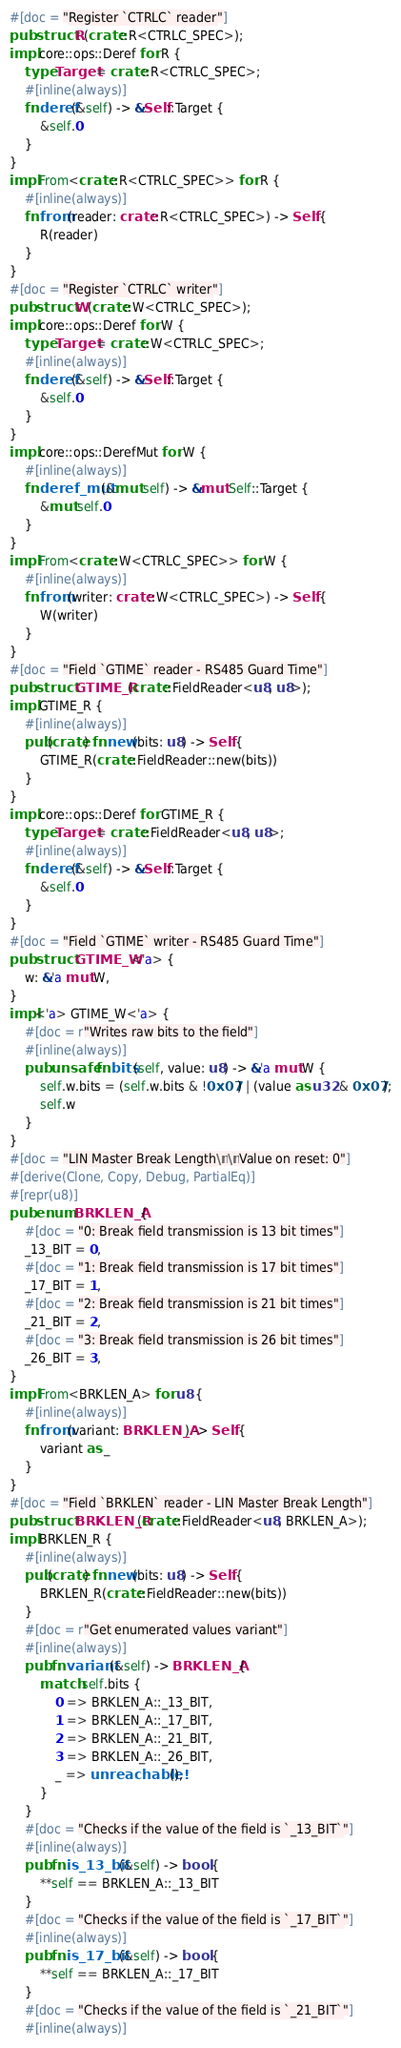<code> <loc_0><loc_0><loc_500><loc_500><_Rust_>#[doc = "Register `CTRLC` reader"]
pub struct R(crate::R<CTRLC_SPEC>);
impl core::ops::Deref for R {
    type Target = crate::R<CTRLC_SPEC>;
    #[inline(always)]
    fn deref(&self) -> &Self::Target {
        &self.0
    }
}
impl From<crate::R<CTRLC_SPEC>> for R {
    #[inline(always)]
    fn from(reader: crate::R<CTRLC_SPEC>) -> Self {
        R(reader)
    }
}
#[doc = "Register `CTRLC` writer"]
pub struct W(crate::W<CTRLC_SPEC>);
impl core::ops::Deref for W {
    type Target = crate::W<CTRLC_SPEC>;
    #[inline(always)]
    fn deref(&self) -> &Self::Target {
        &self.0
    }
}
impl core::ops::DerefMut for W {
    #[inline(always)]
    fn deref_mut(&mut self) -> &mut Self::Target {
        &mut self.0
    }
}
impl From<crate::W<CTRLC_SPEC>> for W {
    #[inline(always)]
    fn from(writer: crate::W<CTRLC_SPEC>) -> Self {
        W(writer)
    }
}
#[doc = "Field `GTIME` reader - RS485 Guard Time"]
pub struct GTIME_R(crate::FieldReader<u8, u8>);
impl GTIME_R {
    #[inline(always)]
    pub(crate) fn new(bits: u8) -> Self {
        GTIME_R(crate::FieldReader::new(bits))
    }
}
impl core::ops::Deref for GTIME_R {
    type Target = crate::FieldReader<u8, u8>;
    #[inline(always)]
    fn deref(&self) -> &Self::Target {
        &self.0
    }
}
#[doc = "Field `GTIME` writer - RS485 Guard Time"]
pub struct GTIME_W<'a> {
    w: &'a mut W,
}
impl<'a> GTIME_W<'a> {
    #[doc = r"Writes raw bits to the field"]
    #[inline(always)]
    pub unsafe fn bits(self, value: u8) -> &'a mut W {
        self.w.bits = (self.w.bits & !0x07) | (value as u32 & 0x07);
        self.w
    }
}
#[doc = "LIN Master Break Length\n\nValue on reset: 0"]
#[derive(Clone, Copy, Debug, PartialEq)]
#[repr(u8)]
pub enum BRKLEN_A {
    #[doc = "0: Break field transmission is 13 bit times"]
    _13_BIT = 0,
    #[doc = "1: Break field transmission is 17 bit times"]
    _17_BIT = 1,
    #[doc = "2: Break field transmission is 21 bit times"]
    _21_BIT = 2,
    #[doc = "3: Break field transmission is 26 bit times"]
    _26_BIT = 3,
}
impl From<BRKLEN_A> for u8 {
    #[inline(always)]
    fn from(variant: BRKLEN_A) -> Self {
        variant as _
    }
}
#[doc = "Field `BRKLEN` reader - LIN Master Break Length"]
pub struct BRKLEN_R(crate::FieldReader<u8, BRKLEN_A>);
impl BRKLEN_R {
    #[inline(always)]
    pub(crate) fn new(bits: u8) -> Self {
        BRKLEN_R(crate::FieldReader::new(bits))
    }
    #[doc = r"Get enumerated values variant"]
    #[inline(always)]
    pub fn variant(&self) -> BRKLEN_A {
        match self.bits {
            0 => BRKLEN_A::_13_BIT,
            1 => BRKLEN_A::_17_BIT,
            2 => BRKLEN_A::_21_BIT,
            3 => BRKLEN_A::_26_BIT,
            _ => unreachable!(),
        }
    }
    #[doc = "Checks if the value of the field is `_13_BIT`"]
    #[inline(always)]
    pub fn is_13_bit(&self) -> bool {
        **self == BRKLEN_A::_13_BIT
    }
    #[doc = "Checks if the value of the field is `_17_BIT`"]
    #[inline(always)]
    pub fn is_17_bit(&self) -> bool {
        **self == BRKLEN_A::_17_BIT
    }
    #[doc = "Checks if the value of the field is `_21_BIT`"]
    #[inline(always)]</code> 